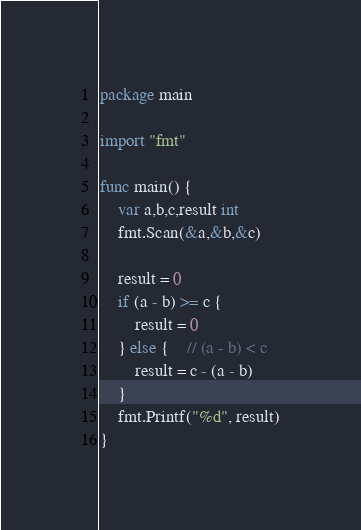Convert code to text. <code><loc_0><loc_0><loc_500><loc_500><_Go_>package main

import "fmt"

func main() {
	var a,b,c,result int
	fmt.Scan(&a,&b,&c)
	
	result = 0
	if (a - b) >= c {
		result = 0
	} else {	// (a - b) < c
		result = c - (a - b)
	}
	fmt.Printf("%d", result)
}</code> 